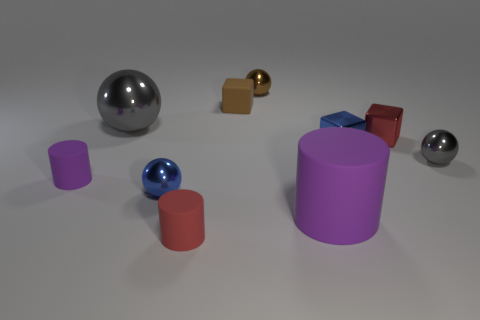Subtract 1 blocks. How many blocks are left? 2 Subtract all large purple rubber cylinders. How many cylinders are left? 2 Subtract all brown balls. How many balls are left? 3 Subtract all cyan balls. Subtract all gray cylinders. How many balls are left? 4 Subtract all cylinders. How many objects are left? 7 Add 6 small gray metallic things. How many small gray metallic things are left? 7 Add 1 large things. How many large things exist? 3 Subtract 1 blue blocks. How many objects are left? 9 Subtract all green objects. Subtract all blue metal things. How many objects are left? 8 